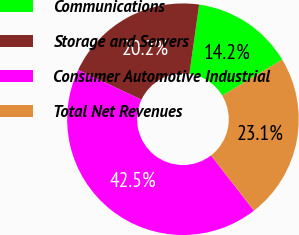<chart> <loc_0><loc_0><loc_500><loc_500><pie_chart><fcel>Communications<fcel>Storage and Servers<fcel>Consumer Automotive Industrial<fcel>Total Net Revenues<nl><fcel>14.17%<fcel>20.24%<fcel>42.51%<fcel>23.08%<nl></chart> 